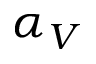Convert formula to latex. <formula><loc_0><loc_0><loc_500><loc_500>\alpha _ { V }</formula> 